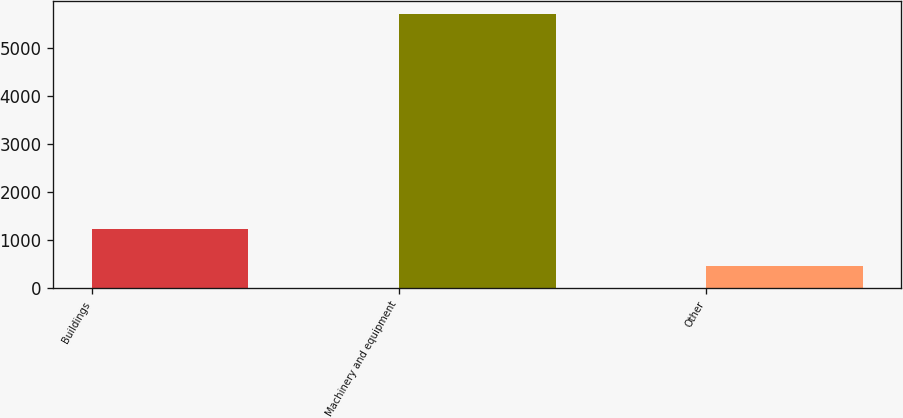Convert chart to OTSL. <chart><loc_0><loc_0><loc_500><loc_500><bar_chart><fcel>Buildings<fcel>Machinery and equipment<fcel>Other<nl><fcel>1224<fcel>5707<fcel>468<nl></chart> 